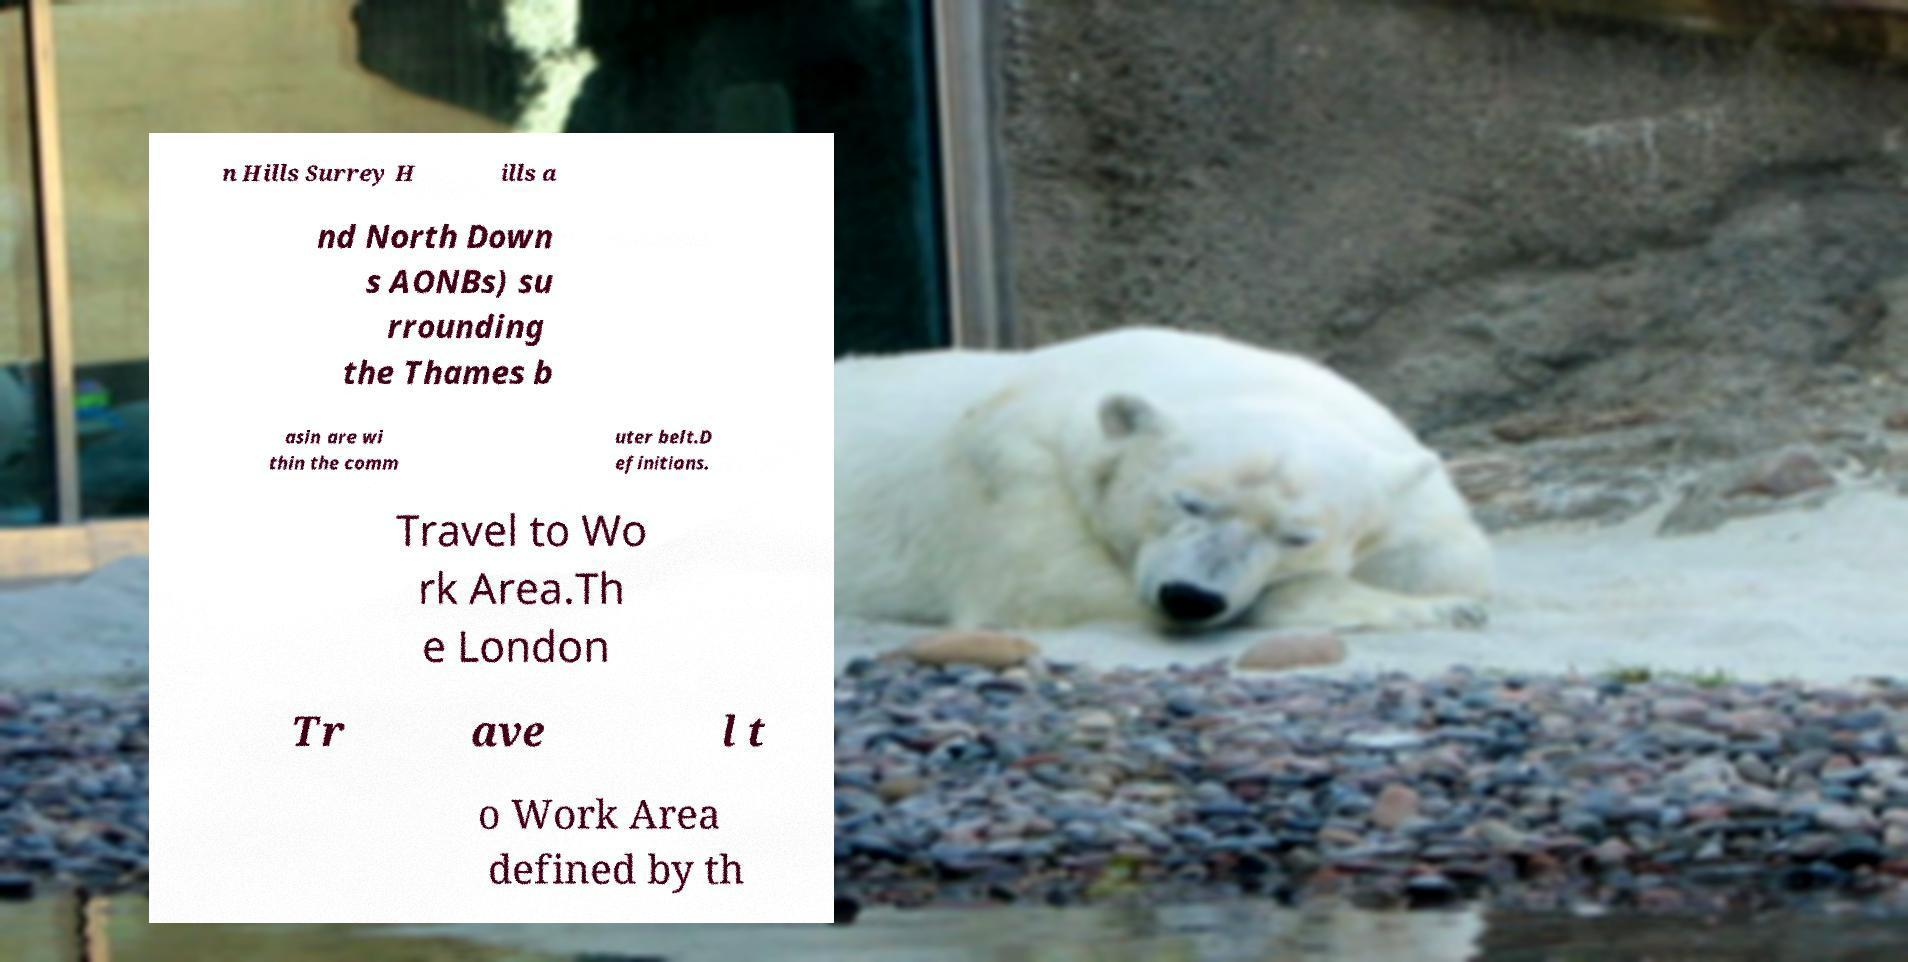Please identify and transcribe the text found in this image. n Hills Surrey H ills a nd North Down s AONBs) su rrounding the Thames b asin are wi thin the comm uter belt.D efinitions. Travel to Wo rk Area.Th e London Tr ave l t o Work Area defined by th 